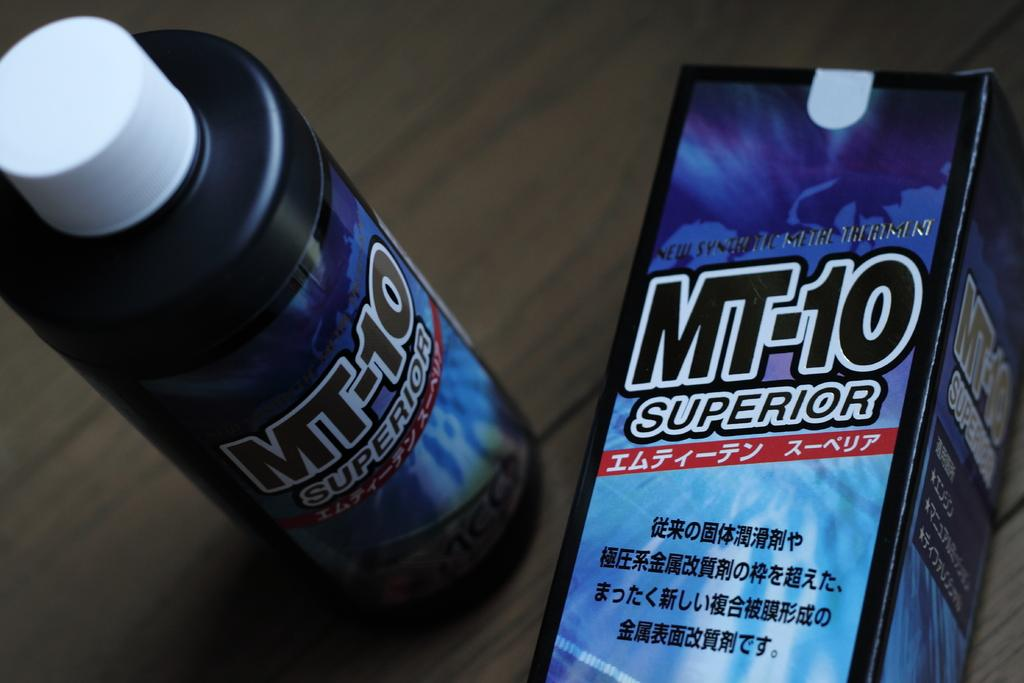What is the color of the bottle in the image? The bottle in the image is black. What other object can be seen in the image besides the bottle? There is a box in the image. What is written on the box? The box has "Superior-10" written on it. What type of meeting is taking place in the image? There is no meeting present in the image; it only features a black bottle and a box with "Superior-10" written on it. What is the coefficient of friction between the bottle and the box in the image? The image does not provide information about the friction between the bottle and the box, nor is there any indication that this is relevant to the image. 